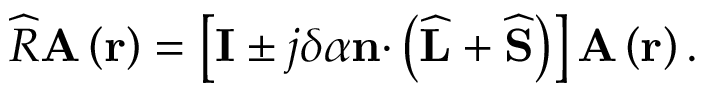Convert formula to latex. <formula><loc_0><loc_0><loc_500><loc_500>\widehat { R } A \left ( r \right ) = \left [ I \pm j \delta \alpha n \cdot \left ( \widehat { L } + \widehat { S } \right ) \right ] A \left ( r \right ) .</formula> 